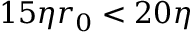<formula> <loc_0><loc_0><loc_500><loc_500>1 5 \eta r _ { 0 } < 2 0 \eta</formula> 